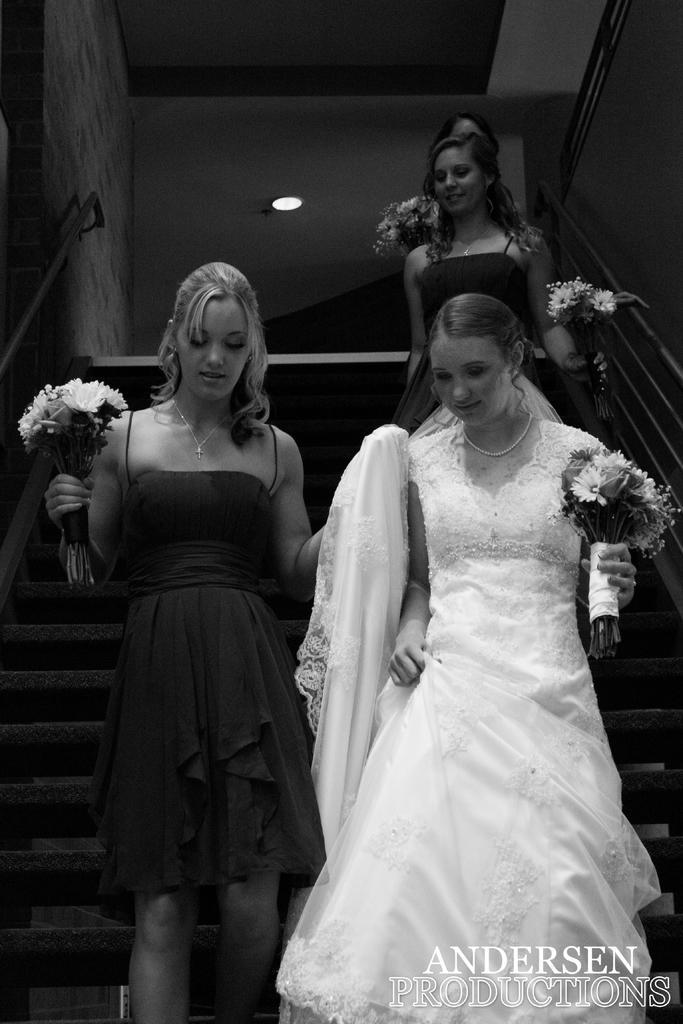Could you give a brief overview of what you see in this image? In this picture we can see few women are on the state cases, they are holding some flowers, among them one woman is wearing white dress. 